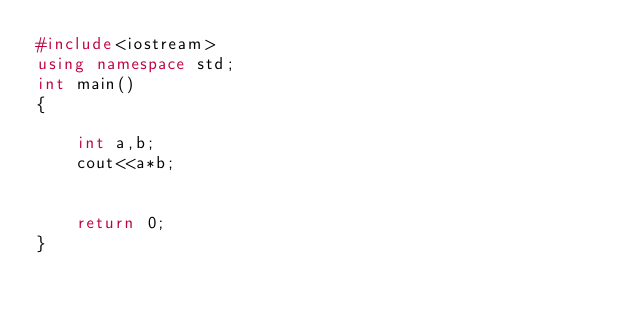<code> <loc_0><loc_0><loc_500><loc_500><_C++_>#include<iostream>
using namespace std;
int main()
{
    
    int a,b;
    cout<<a*b;
    
    
    return 0;
}</code> 